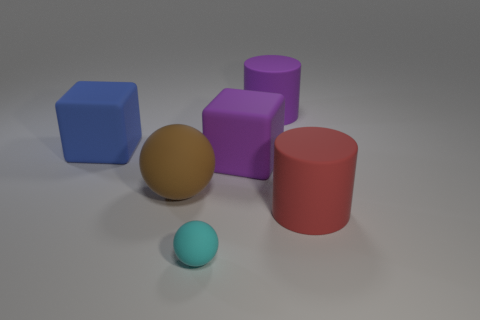How many other objects are there of the same shape as the red rubber thing?
Provide a succinct answer. 1. What is the size of the thing behind the block to the left of the matte sphere behind the cyan matte sphere?
Provide a succinct answer. Large. What number of purple objects are large rubber spheres or big cylinders?
Make the answer very short. 1. What is the shape of the large purple thing that is behind the cube that is behind the big purple block?
Offer a very short reply. Cylinder. There is a thing that is in front of the red rubber thing; is it the same size as the rubber cylinder that is behind the big purple block?
Keep it short and to the point. No. Is there a sphere made of the same material as the large purple cylinder?
Provide a succinct answer. Yes. Is there a large brown rubber ball that is behind the matte cylinder in front of the sphere to the left of the cyan sphere?
Ensure brevity in your answer.  Yes. There is a big purple cube; are there any large purple cylinders to the left of it?
Your answer should be very brief. No. How many matte objects are behind the big block that is on the left side of the small matte object?
Your answer should be compact. 1. There is a purple block; is it the same size as the thing on the left side of the big brown ball?
Your answer should be compact. Yes. 